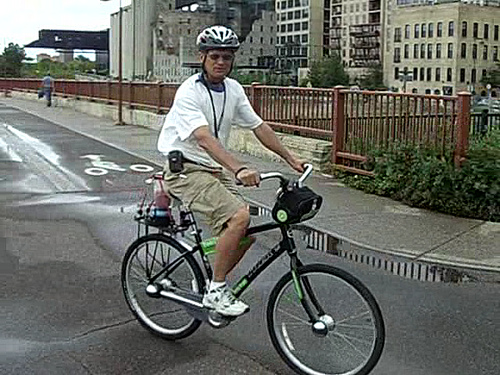What is above the bicycle? Positioned above the bicycle is a man who appears to be engaged in a leisurely bike ride. He is appropriately dressed for cycling, wearing a helmet for safety, a white shirt, and shorts. The focus on safety is further exemplified by his selection of bright footwear, enhancing visibility. 